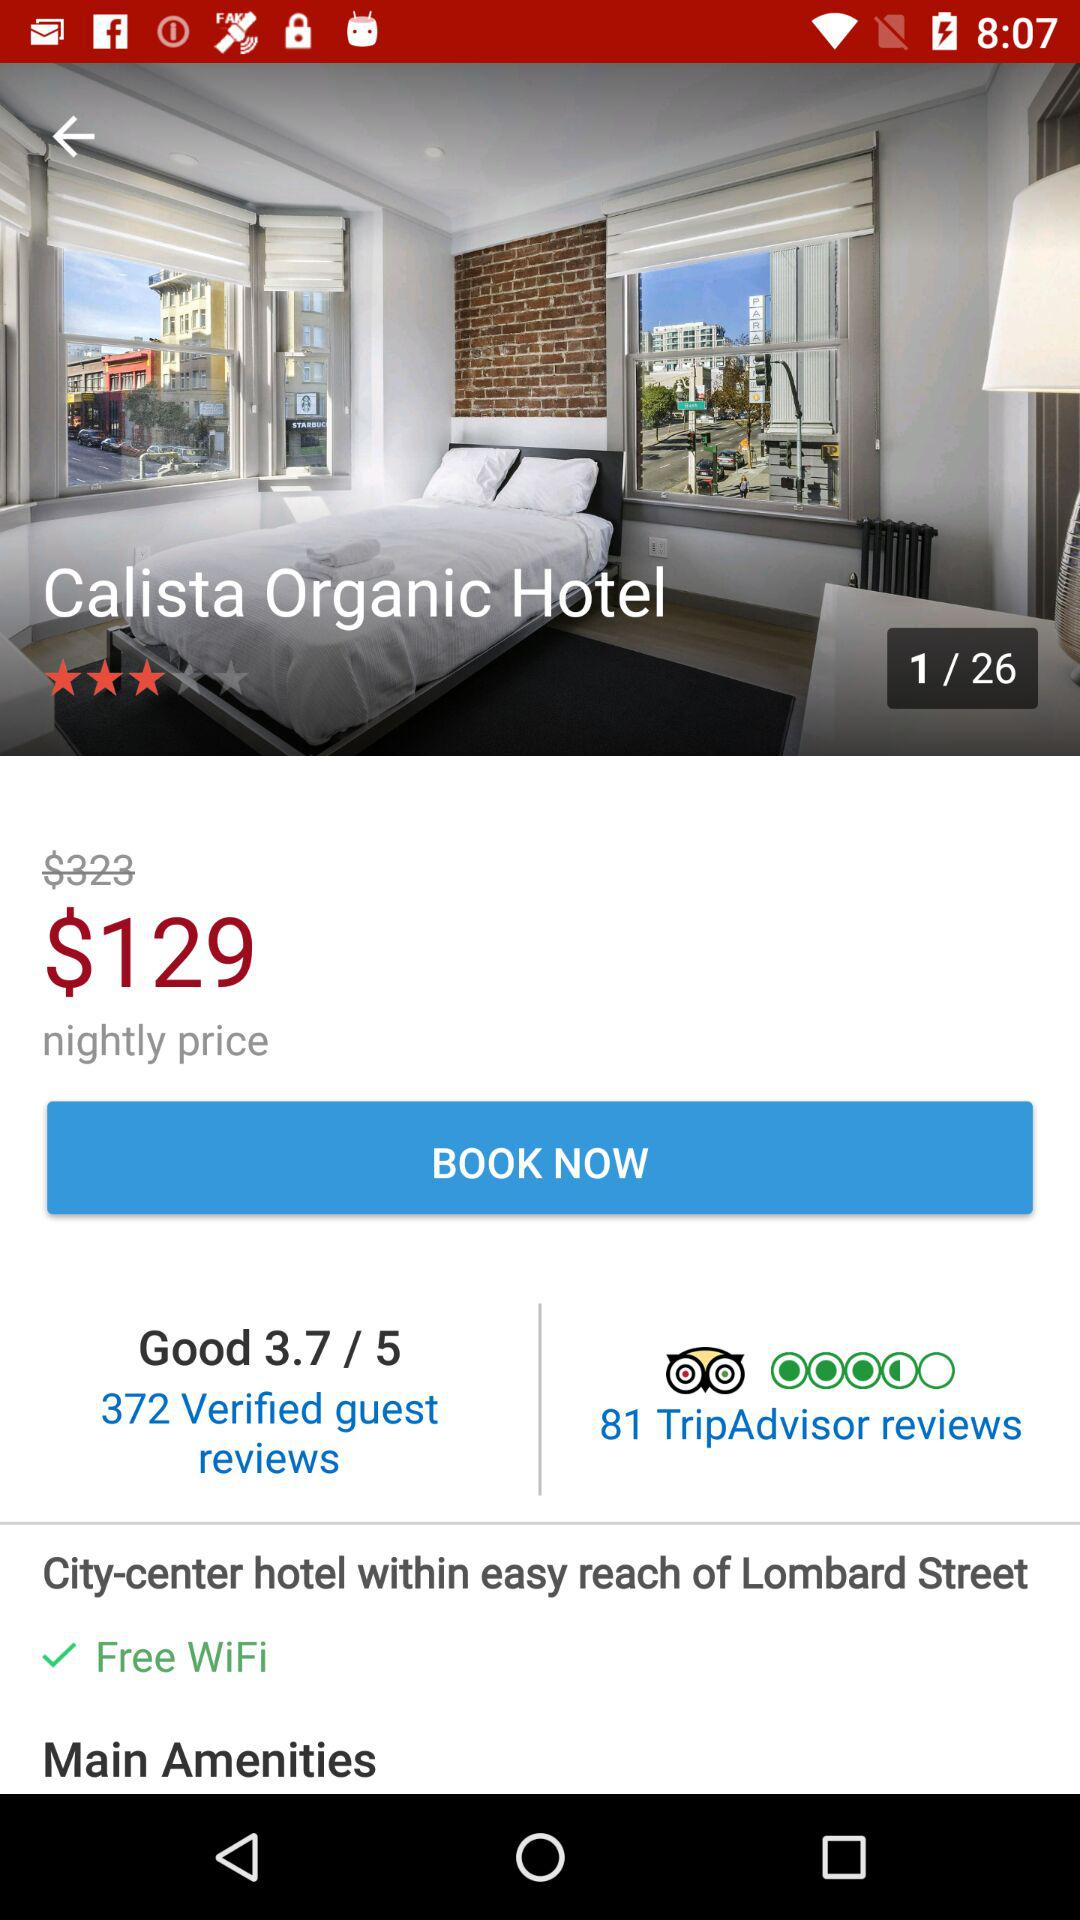How many reviews are there by trip advisors? There are 81 reviews by trip advisors. 